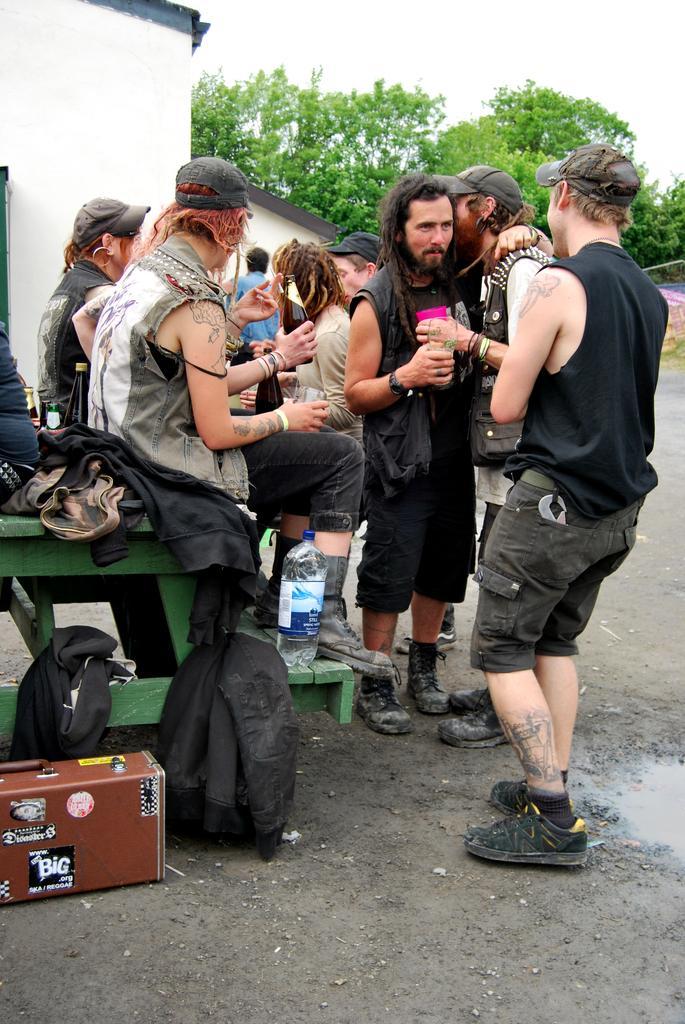How would you summarize this image in a sentence or two? In this image we can see few people. Some are standing and some are sitting. Some are wearing caps and holding something in the hands. Also there is a stand. On the stand there are clothes and bottle. Near to that there is a box on the floor. In the back there are trees and a building. In the background there is sky. 